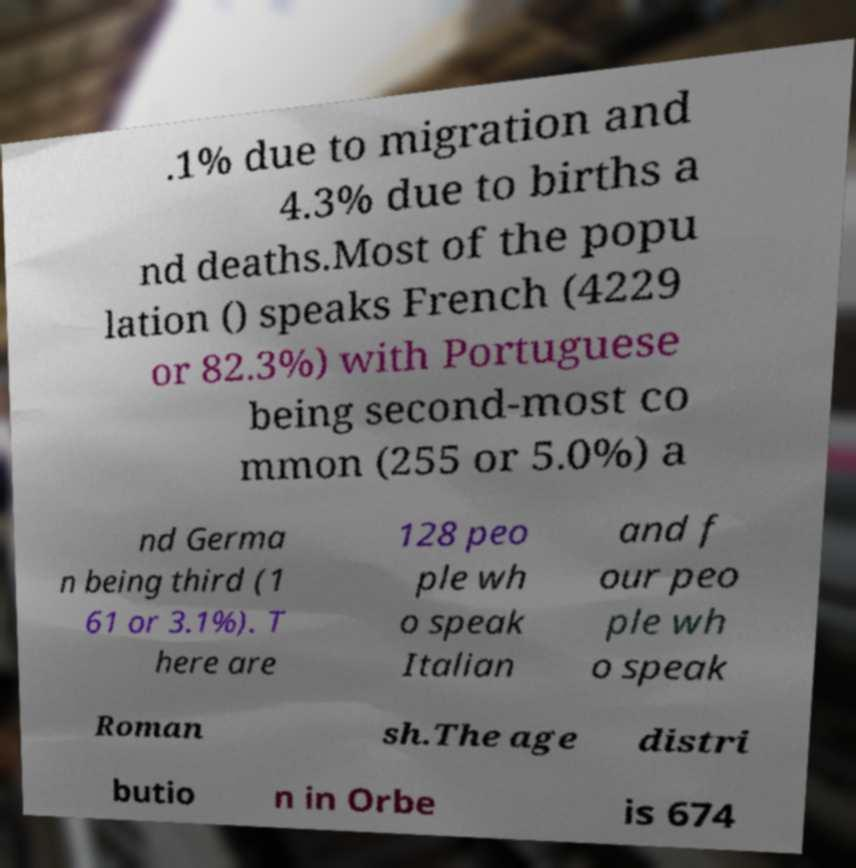Could you extract and type out the text from this image? .1% due to migration and 4.3% due to births a nd deaths.Most of the popu lation () speaks French (4229 or 82.3%) with Portuguese being second-most co mmon (255 or 5.0%) a nd Germa n being third (1 61 or 3.1%). T here are 128 peo ple wh o speak Italian and f our peo ple wh o speak Roman sh.The age distri butio n in Orbe is 674 